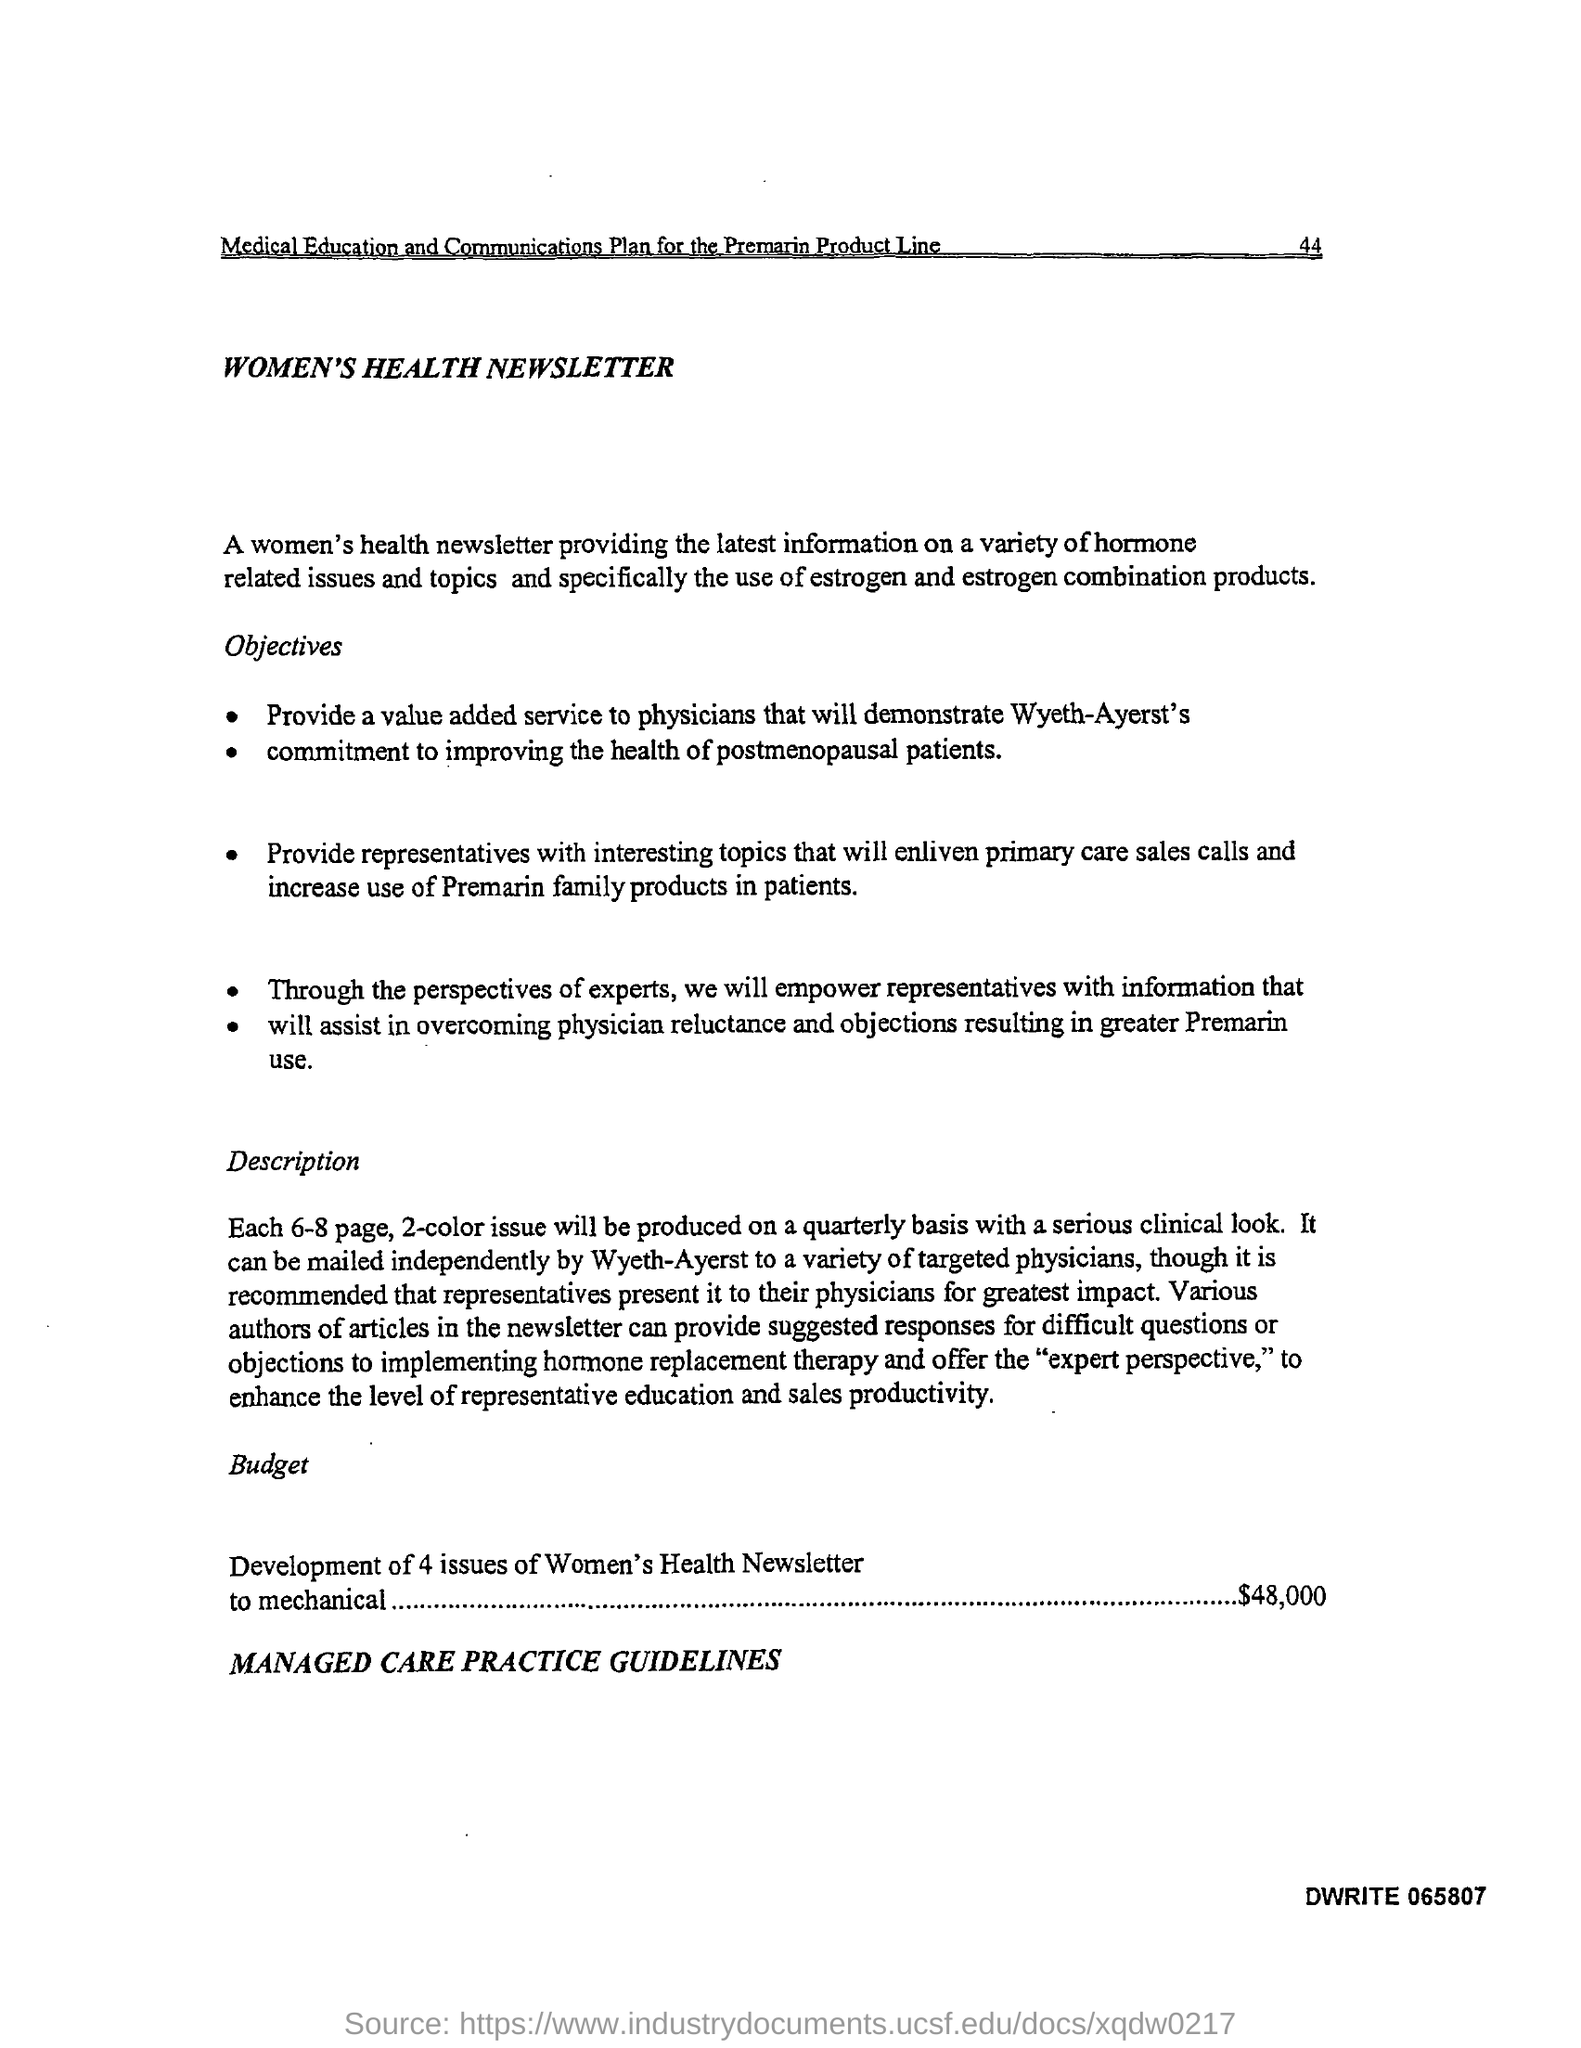What is the Title of the document?
Offer a terse response. Women's Health Newsletter. What is the Budget for Development of 4 issues of Women's Health Newsletter to mechanical?
Offer a very short reply. $48,000. 